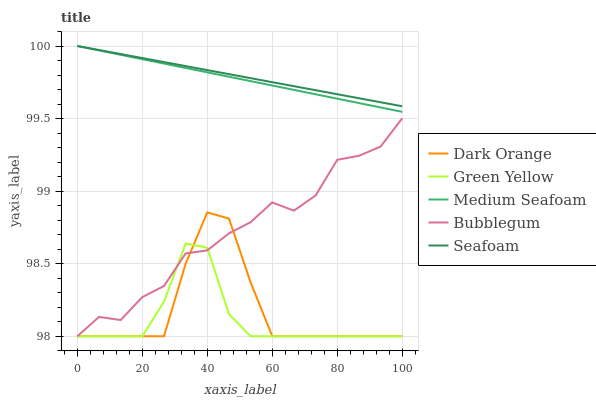Does Green Yellow have the minimum area under the curve?
Answer yes or no. Yes. Does Seafoam have the maximum area under the curve?
Answer yes or no. Yes. Does Medium Seafoam have the minimum area under the curve?
Answer yes or no. No. Does Medium Seafoam have the maximum area under the curve?
Answer yes or no. No. Is Seafoam the smoothest?
Answer yes or no. Yes. Is Dark Orange the roughest?
Answer yes or no. Yes. Is Green Yellow the smoothest?
Answer yes or no. No. Is Green Yellow the roughest?
Answer yes or no. No. Does Medium Seafoam have the lowest value?
Answer yes or no. No. Does Green Yellow have the highest value?
Answer yes or no. No. Is Green Yellow less than Medium Seafoam?
Answer yes or no. Yes. Is Seafoam greater than Green Yellow?
Answer yes or no. Yes. Does Green Yellow intersect Medium Seafoam?
Answer yes or no. No. 